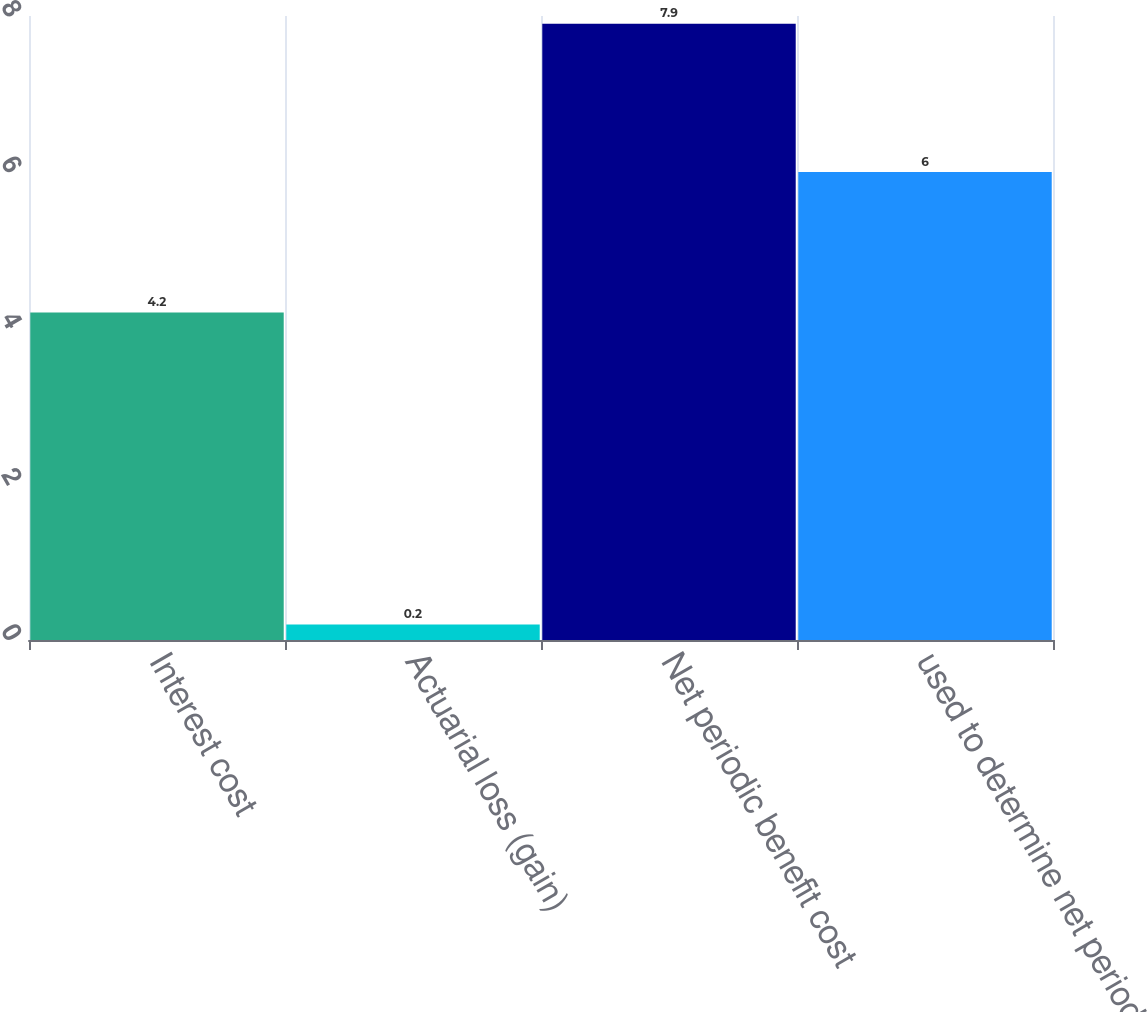Convert chart to OTSL. <chart><loc_0><loc_0><loc_500><loc_500><bar_chart><fcel>Interest cost<fcel>Actuarial loss (gain)<fcel>Net periodic benefit cost<fcel>used to determine net periodic<nl><fcel>4.2<fcel>0.2<fcel>7.9<fcel>6<nl></chart> 